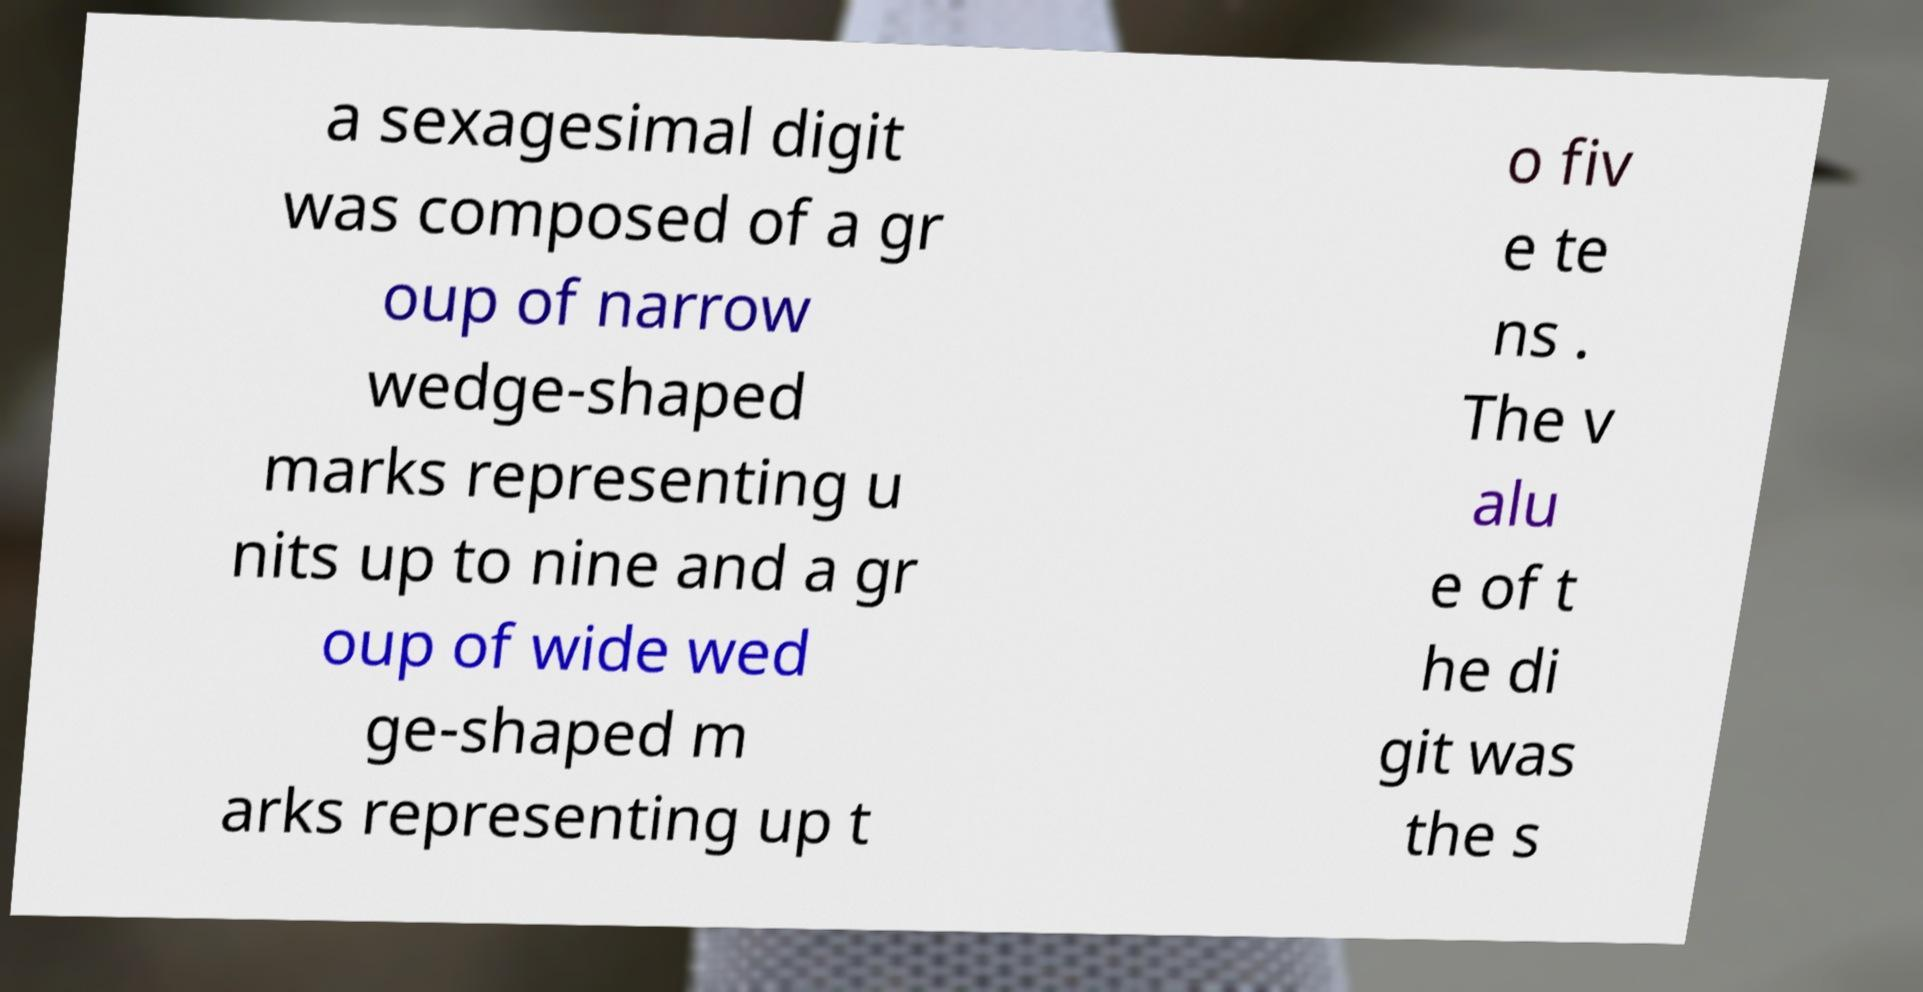Can you read and provide the text displayed in the image?This photo seems to have some interesting text. Can you extract and type it out for me? a sexagesimal digit was composed of a gr oup of narrow wedge-shaped marks representing u nits up to nine and a gr oup of wide wed ge-shaped m arks representing up t o fiv e te ns . The v alu e of t he di git was the s 